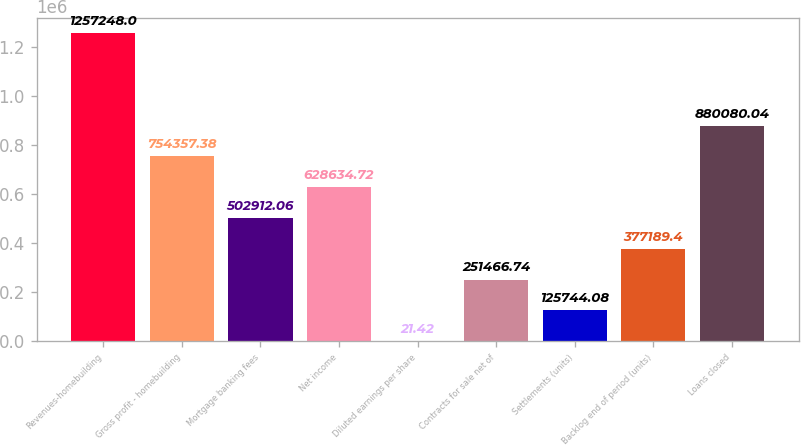<chart> <loc_0><loc_0><loc_500><loc_500><bar_chart><fcel>Revenues-homebuilding<fcel>Gross profit - homebuilding<fcel>Mortgage banking fees<fcel>Net income<fcel>Diluted earnings per share<fcel>Contracts for sale net of<fcel>Settlements (units)<fcel>Backlog end of period (units)<fcel>Loans closed<nl><fcel>1.25725e+06<fcel>754357<fcel>502912<fcel>628635<fcel>21.42<fcel>251467<fcel>125744<fcel>377189<fcel>880080<nl></chart> 